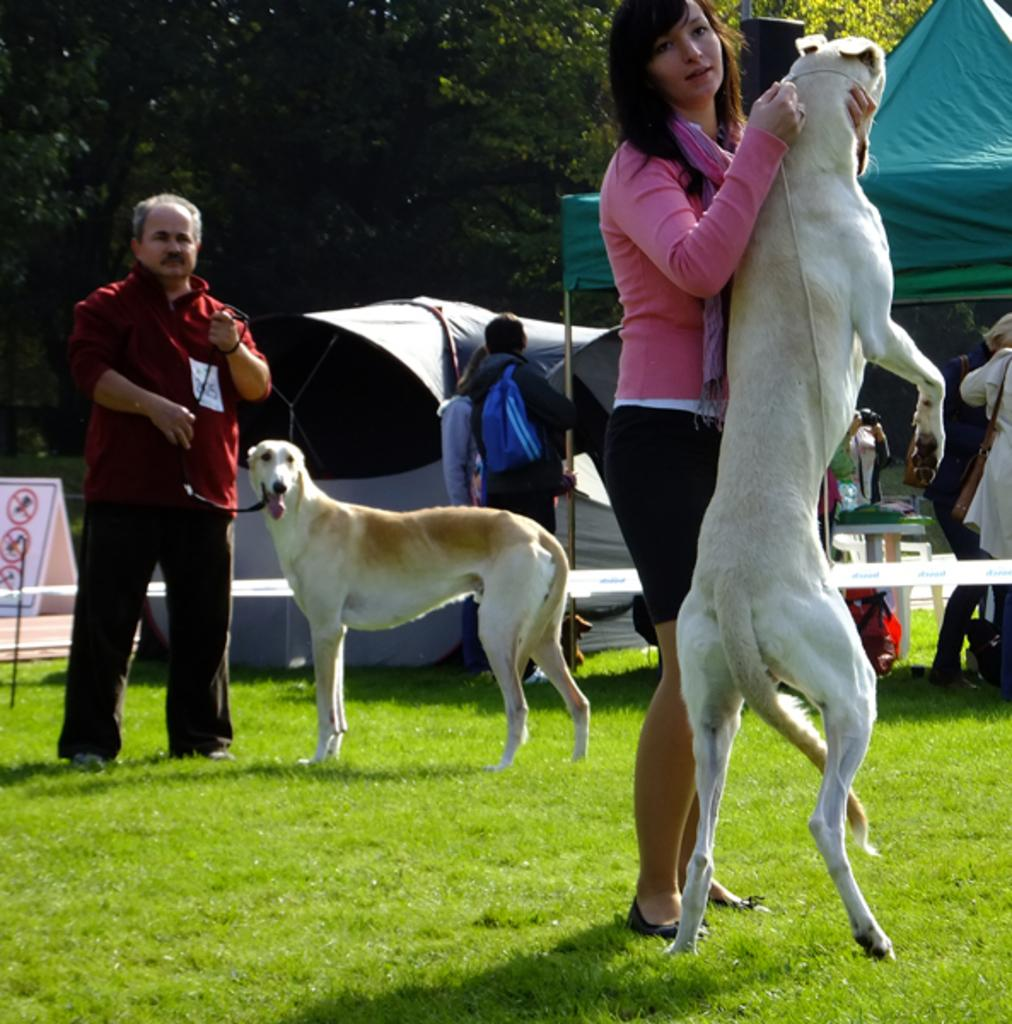Who is holding an animal in the image? The woman is holding a dog in the image. What is the man holding in the image? The man is holding a belt in the image. What is the relationship between the belt and the dog? The belt is tied to the dog in the image. What can be seen in the background of the image? There are people, a tent, and trees in the background of the image. How many babies are present in the image? There are no babies present in the image. What type of kitty can be seen playing with the belt in the image? There is no kitty present in the image, and the belt is tied to the dog, not a kitty. 